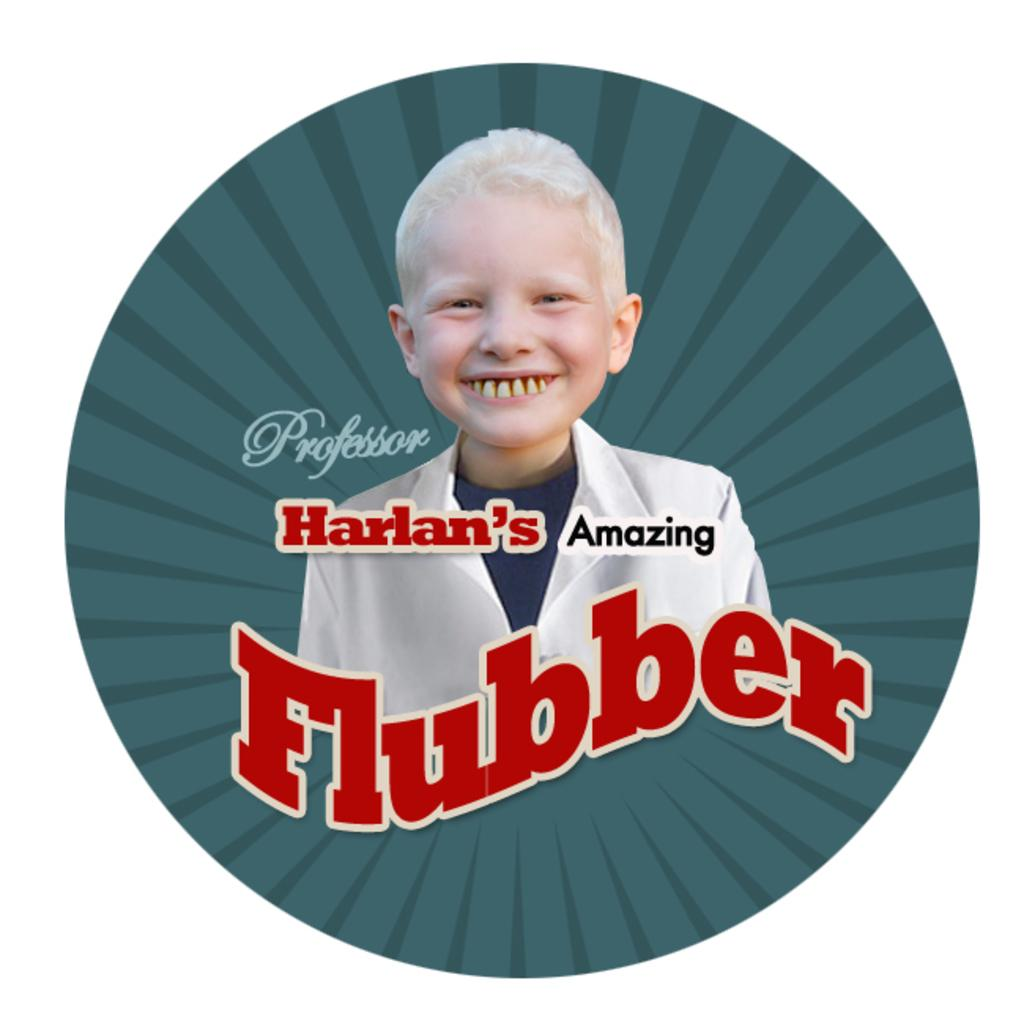<image>
Relay a brief, clear account of the picture shown. A logo for Harlan's Amazing Flubber with a blue background. 